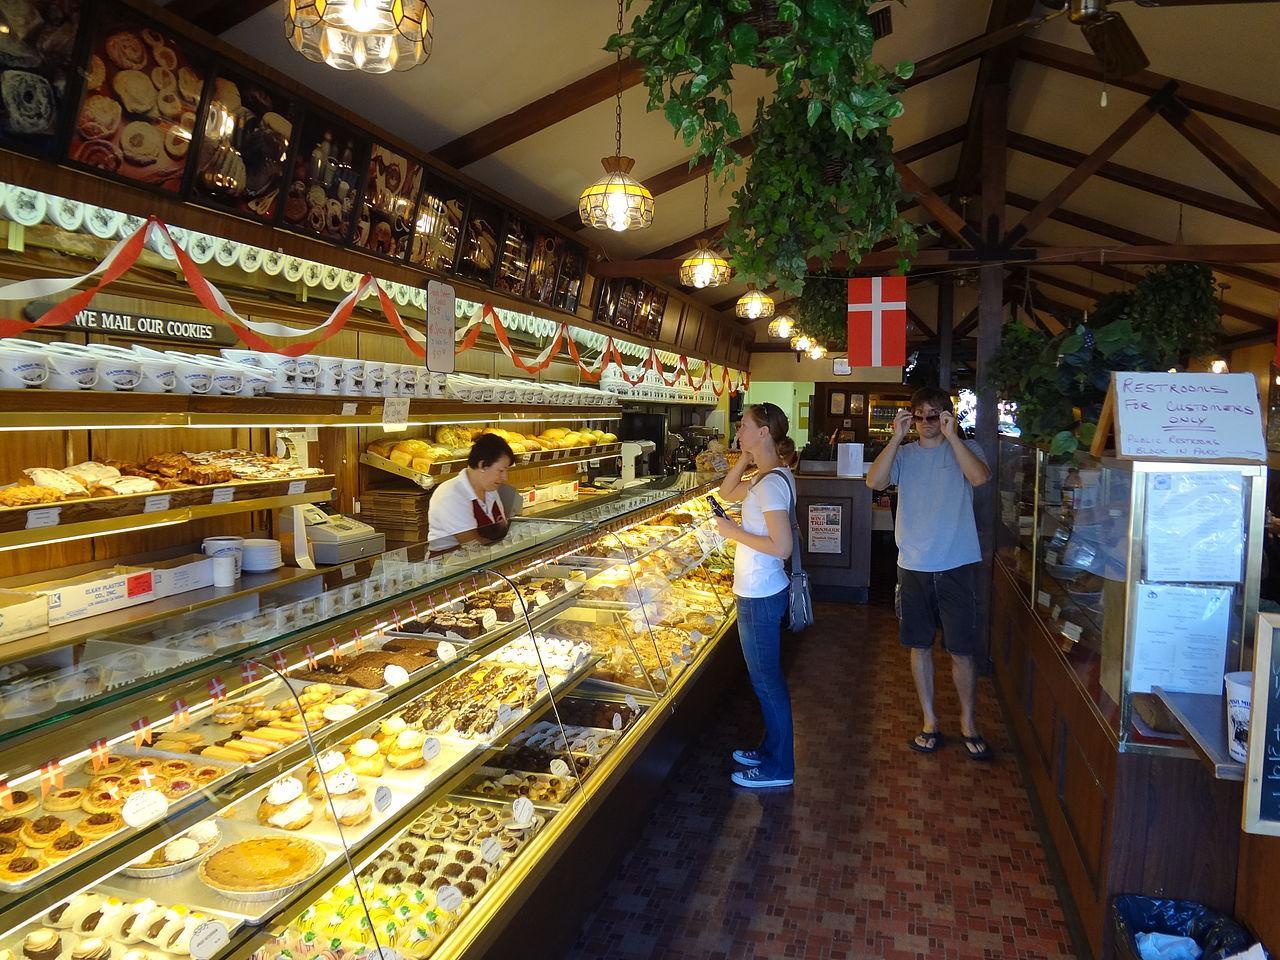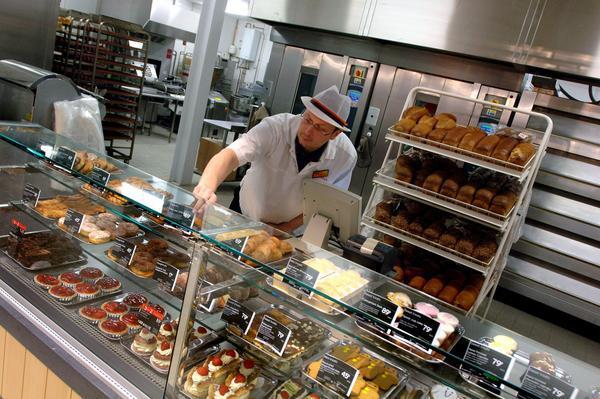The first image is the image on the left, the second image is the image on the right. For the images shown, is this caption "The right image shows at least one person in a hat standing behind a straight glass-fronted cabinet filled with baked treats." true? Answer yes or no. Yes. The first image is the image on the left, the second image is the image on the right. Considering the images on both sides, is "In the left image, the word bakery is present." valid? Answer yes or no. No. 